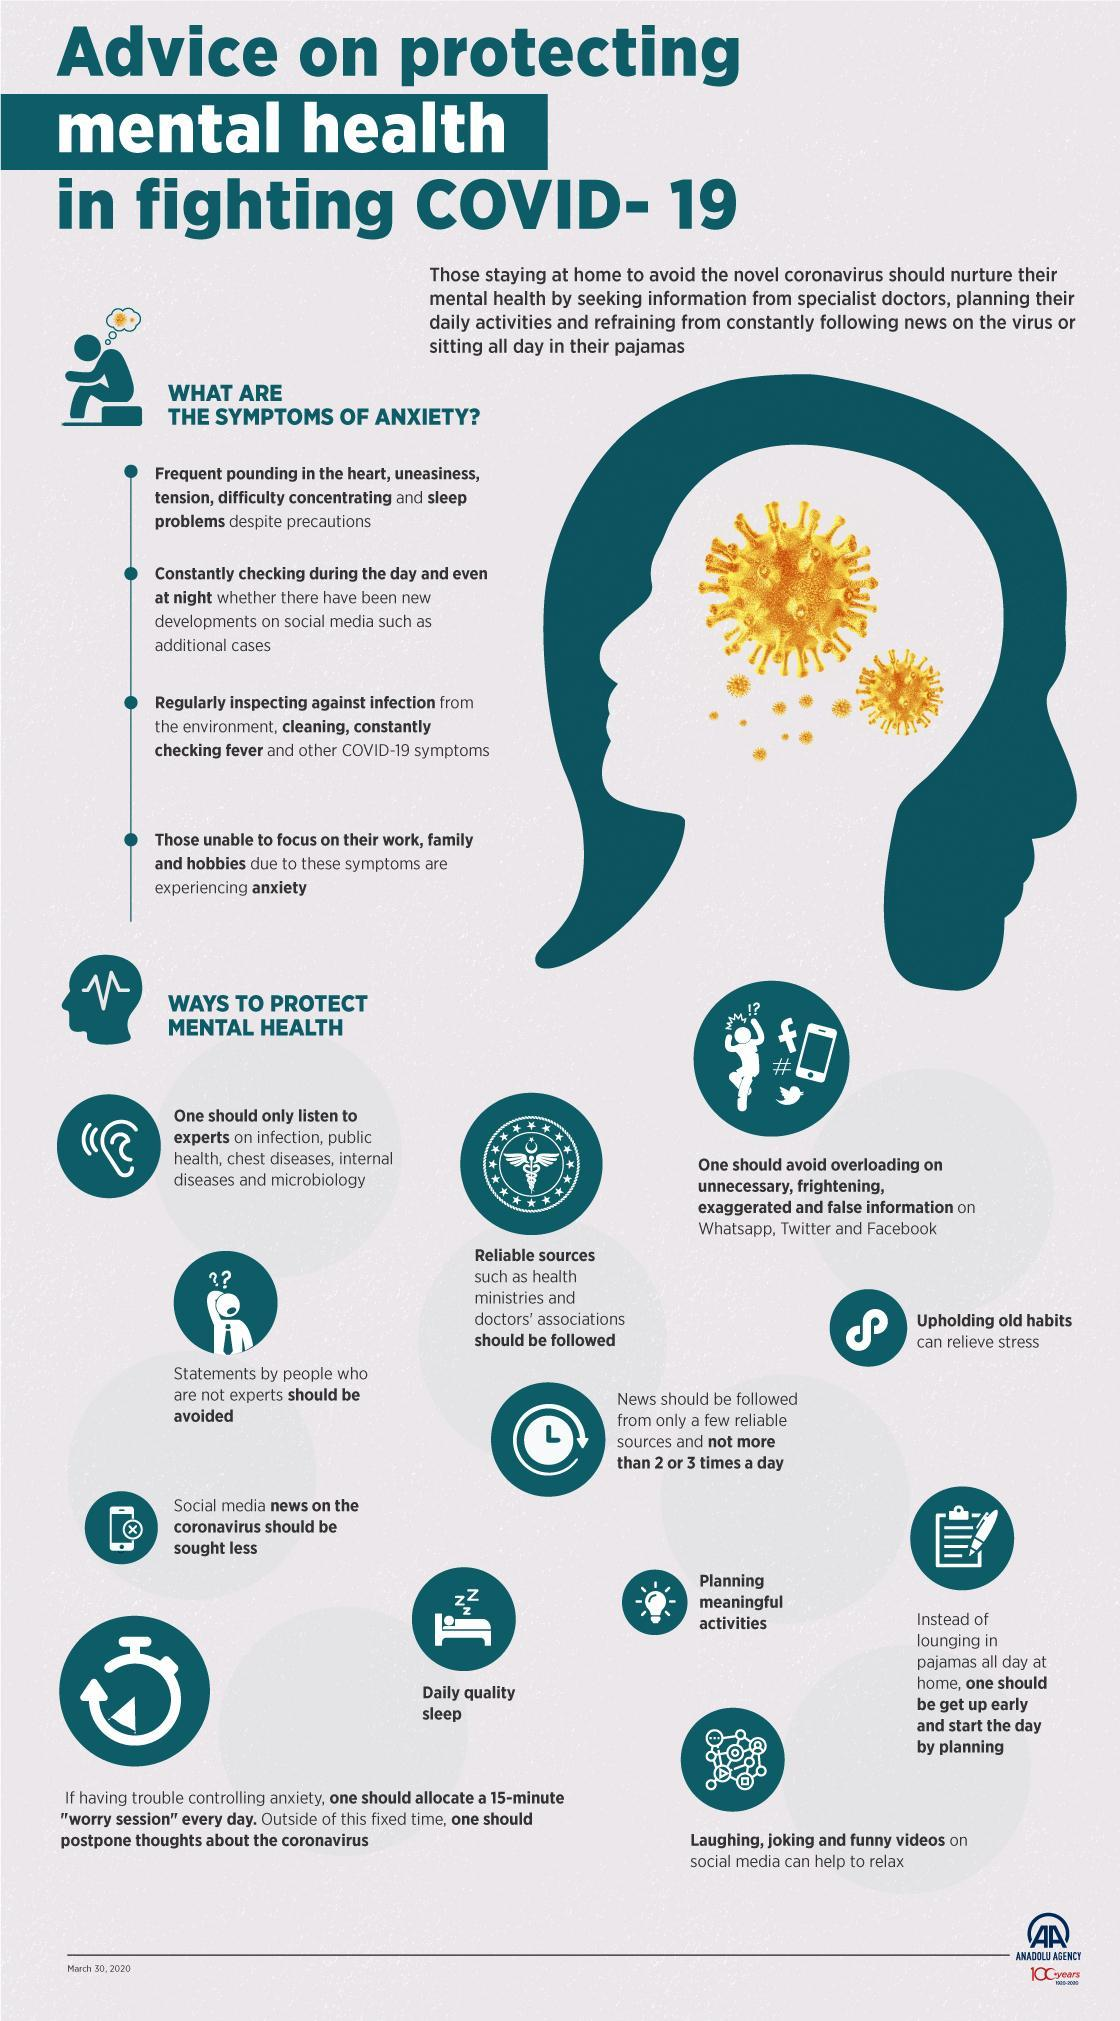What are the social media activities that can be relaxing?
Answer the question with a short phrase. Laughing, joking and funny videos What are the reliable sources of information that should be followed? Health ministries and doctors' associations Which mental health strategy is represented by the picture of a bulb? Planning meaningful activities How can upholding old habits help? Relieve stress How many bullet points are there under symptoms of anxiety? 4 How frequently should news be followed? Not more than 2 or 3 times a day What are the symptoms mentioned under the first bullet point? Frequent pounding in the heart, uneasiness, tension, difficulty concentrating and sleep problems despite precautions What kind of sleep is required for a healthy mind? Daily quality sleep Which social media platforms generally have unnecessary exaggerated information on coronavirus? WhatsApp, Twitter and Facebook Whose statements are to be ignored? People who or not experts Whose opinion on public health infection and other diseases should we rely on? Experts Whitch news is less reliable for information relating to coronavirus? Social media news 